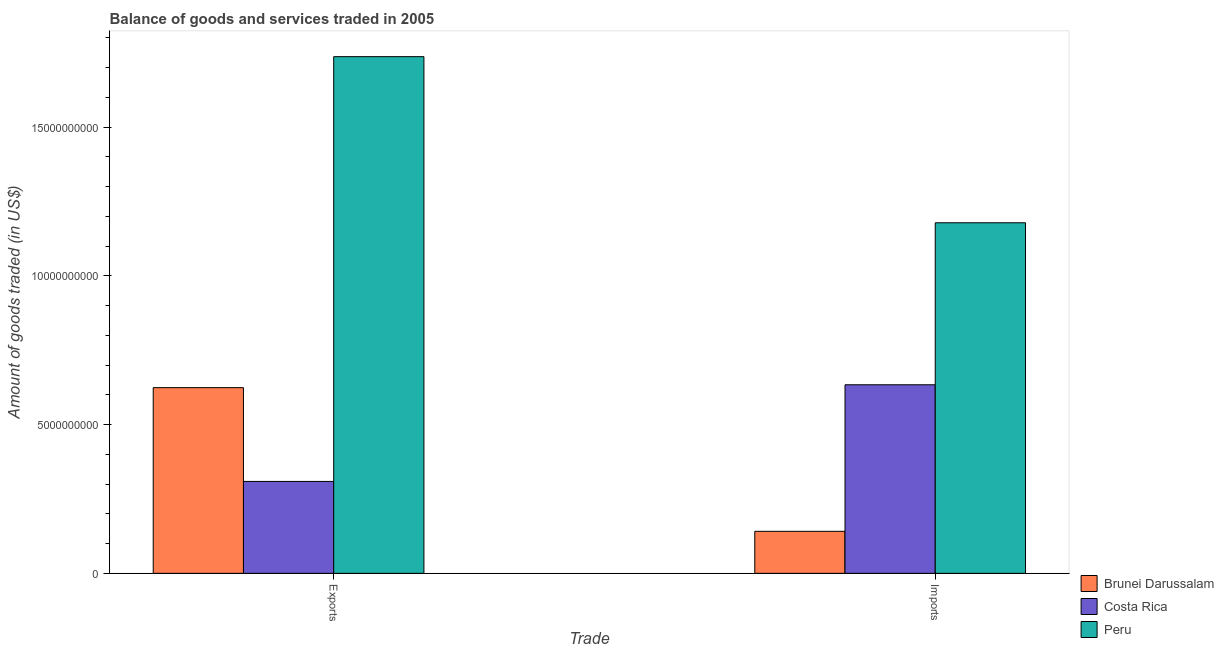How many groups of bars are there?
Ensure brevity in your answer.  2. Are the number of bars per tick equal to the number of legend labels?
Your response must be concise. Yes. Are the number of bars on each tick of the X-axis equal?
Keep it short and to the point. Yes. How many bars are there on the 2nd tick from the right?
Give a very brief answer. 3. What is the label of the 2nd group of bars from the left?
Provide a short and direct response. Imports. What is the amount of goods exported in Brunei Darussalam?
Ensure brevity in your answer.  6.24e+09. Across all countries, what is the maximum amount of goods imported?
Make the answer very short. 1.18e+1. Across all countries, what is the minimum amount of goods imported?
Give a very brief answer. 1.41e+09. In which country was the amount of goods exported maximum?
Offer a terse response. Peru. In which country was the amount of goods imported minimum?
Offer a very short reply. Brunei Darussalam. What is the total amount of goods exported in the graph?
Keep it short and to the point. 2.67e+1. What is the difference between the amount of goods exported in Brunei Darussalam and that in Costa Rica?
Offer a terse response. 3.15e+09. What is the difference between the amount of goods exported in Peru and the amount of goods imported in Costa Rica?
Your answer should be very brief. 1.10e+1. What is the average amount of goods exported per country?
Provide a short and direct response. 8.90e+09. What is the difference between the amount of goods imported and amount of goods exported in Costa Rica?
Ensure brevity in your answer.  3.25e+09. What is the ratio of the amount of goods exported in Brunei Darussalam to that in Costa Rica?
Provide a succinct answer. 2.02. Is the amount of goods imported in Costa Rica less than that in Peru?
Your response must be concise. Yes. In how many countries, is the amount of goods imported greater than the average amount of goods imported taken over all countries?
Ensure brevity in your answer.  1. What does the 2nd bar from the right in Imports represents?
Your answer should be compact. Costa Rica. How many bars are there?
Your answer should be compact. 6. Are all the bars in the graph horizontal?
Offer a very short reply. No. What is the difference between two consecutive major ticks on the Y-axis?
Provide a succinct answer. 5.00e+09. Are the values on the major ticks of Y-axis written in scientific E-notation?
Your answer should be very brief. No. Does the graph contain any zero values?
Your response must be concise. No. Where does the legend appear in the graph?
Your answer should be compact. Bottom right. How are the legend labels stacked?
Provide a succinct answer. Vertical. What is the title of the graph?
Provide a succinct answer. Balance of goods and services traded in 2005. Does "Venezuela" appear as one of the legend labels in the graph?
Offer a terse response. No. What is the label or title of the X-axis?
Offer a very short reply. Trade. What is the label or title of the Y-axis?
Your answer should be very brief. Amount of goods traded (in US$). What is the Amount of goods traded (in US$) of Brunei Darussalam in Exports?
Make the answer very short. 6.24e+09. What is the Amount of goods traded (in US$) in Costa Rica in Exports?
Give a very brief answer. 3.09e+09. What is the Amount of goods traded (in US$) in Peru in Exports?
Offer a very short reply. 1.74e+1. What is the Amount of goods traded (in US$) of Brunei Darussalam in Imports?
Your response must be concise. 1.41e+09. What is the Amount of goods traded (in US$) in Costa Rica in Imports?
Keep it short and to the point. 6.34e+09. What is the Amount of goods traded (in US$) of Peru in Imports?
Your response must be concise. 1.18e+1. Across all Trade, what is the maximum Amount of goods traded (in US$) in Brunei Darussalam?
Provide a short and direct response. 6.24e+09. Across all Trade, what is the maximum Amount of goods traded (in US$) in Costa Rica?
Your answer should be very brief. 6.34e+09. Across all Trade, what is the maximum Amount of goods traded (in US$) of Peru?
Ensure brevity in your answer.  1.74e+1. Across all Trade, what is the minimum Amount of goods traded (in US$) in Brunei Darussalam?
Your response must be concise. 1.41e+09. Across all Trade, what is the minimum Amount of goods traded (in US$) in Costa Rica?
Your response must be concise. 3.09e+09. Across all Trade, what is the minimum Amount of goods traded (in US$) of Peru?
Offer a very short reply. 1.18e+1. What is the total Amount of goods traded (in US$) in Brunei Darussalam in the graph?
Give a very brief answer. 7.65e+09. What is the total Amount of goods traded (in US$) in Costa Rica in the graph?
Offer a very short reply. 9.43e+09. What is the total Amount of goods traded (in US$) of Peru in the graph?
Make the answer very short. 2.91e+1. What is the difference between the Amount of goods traded (in US$) of Brunei Darussalam in Exports and that in Imports?
Provide a short and direct response. 4.83e+09. What is the difference between the Amount of goods traded (in US$) of Costa Rica in Exports and that in Imports?
Your answer should be compact. -3.25e+09. What is the difference between the Amount of goods traded (in US$) of Peru in Exports and that in Imports?
Your response must be concise. 5.58e+09. What is the difference between the Amount of goods traded (in US$) of Brunei Darussalam in Exports and the Amount of goods traded (in US$) of Costa Rica in Imports?
Your answer should be very brief. -9.66e+07. What is the difference between the Amount of goods traded (in US$) of Brunei Darussalam in Exports and the Amount of goods traded (in US$) of Peru in Imports?
Offer a very short reply. -5.54e+09. What is the difference between the Amount of goods traded (in US$) of Costa Rica in Exports and the Amount of goods traded (in US$) of Peru in Imports?
Your answer should be very brief. -8.69e+09. What is the average Amount of goods traded (in US$) in Brunei Darussalam per Trade?
Your response must be concise. 3.83e+09. What is the average Amount of goods traded (in US$) of Costa Rica per Trade?
Your answer should be very brief. 4.71e+09. What is the average Amount of goods traded (in US$) in Peru per Trade?
Your answer should be compact. 1.46e+1. What is the difference between the Amount of goods traded (in US$) in Brunei Darussalam and Amount of goods traded (in US$) in Costa Rica in Exports?
Give a very brief answer. 3.15e+09. What is the difference between the Amount of goods traded (in US$) of Brunei Darussalam and Amount of goods traded (in US$) of Peru in Exports?
Provide a succinct answer. -1.11e+1. What is the difference between the Amount of goods traded (in US$) in Costa Rica and Amount of goods traded (in US$) in Peru in Exports?
Your answer should be compact. -1.43e+1. What is the difference between the Amount of goods traded (in US$) in Brunei Darussalam and Amount of goods traded (in US$) in Costa Rica in Imports?
Make the answer very short. -4.93e+09. What is the difference between the Amount of goods traded (in US$) of Brunei Darussalam and Amount of goods traded (in US$) of Peru in Imports?
Provide a short and direct response. -1.04e+1. What is the difference between the Amount of goods traded (in US$) in Costa Rica and Amount of goods traded (in US$) in Peru in Imports?
Make the answer very short. -5.44e+09. What is the ratio of the Amount of goods traded (in US$) of Brunei Darussalam in Exports to that in Imports?
Provide a short and direct response. 4.42. What is the ratio of the Amount of goods traded (in US$) in Costa Rica in Exports to that in Imports?
Provide a short and direct response. 0.49. What is the ratio of the Amount of goods traded (in US$) in Peru in Exports to that in Imports?
Your answer should be very brief. 1.47. What is the difference between the highest and the second highest Amount of goods traded (in US$) in Brunei Darussalam?
Give a very brief answer. 4.83e+09. What is the difference between the highest and the second highest Amount of goods traded (in US$) of Costa Rica?
Provide a succinct answer. 3.25e+09. What is the difference between the highest and the second highest Amount of goods traded (in US$) in Peru?
Offer a very short reply. 5.58e+09. What is the difference between the highest and the lowest Amount of goods traded (in US$) of Brunei Darussalam?
Offer a terse response. 4.83e+09. What is the difference between the highest and the lowest Amount of goods traded (in US$) in Costa Rica?
Give a very brief answer. 3.25e+09. What is the difference between the highest and the lowest Amount of goods traded (in US$) of Peru?
Your response must be concise. 5.58e+09. 